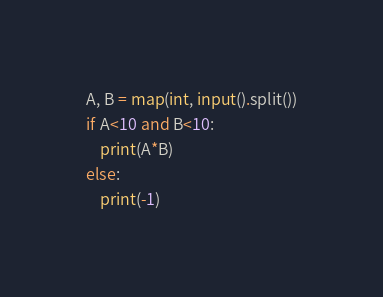Convert code to text. <code><loc_0><loc_0><loc_500><loc_500><_Python_>A, B = map(int, input().split())
if A<10 and B<10:
    print(A*B)
else:
    print(-1)</code> 